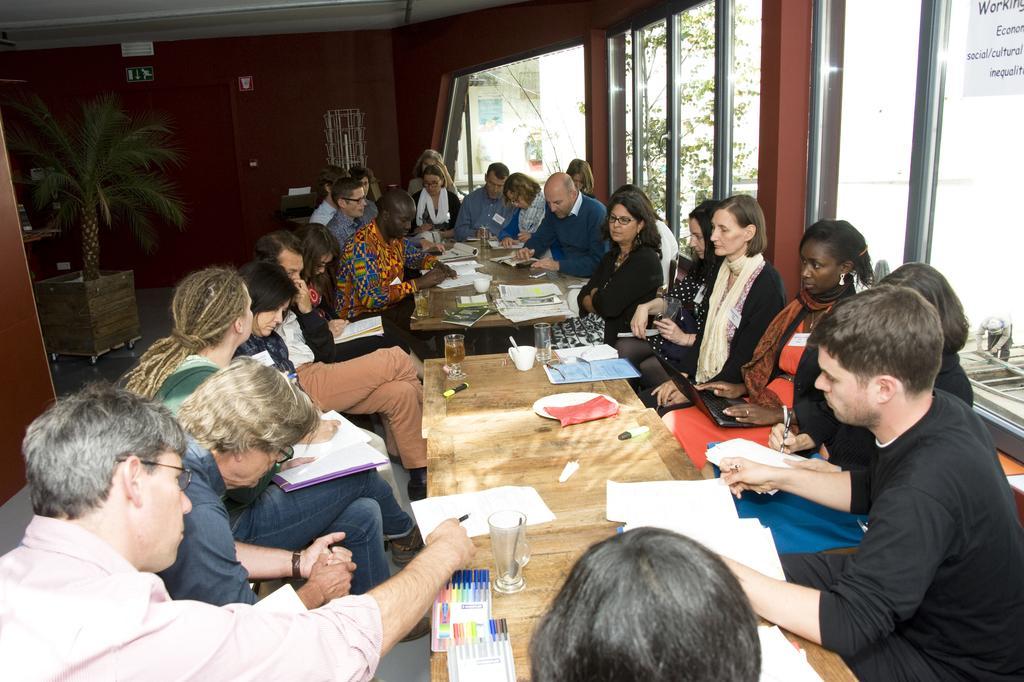Describe this image in one or two sentences. In this image I can see number of people are sitting. On this table I can see few pens, papers and few glasses. In the background I can see a plant. 